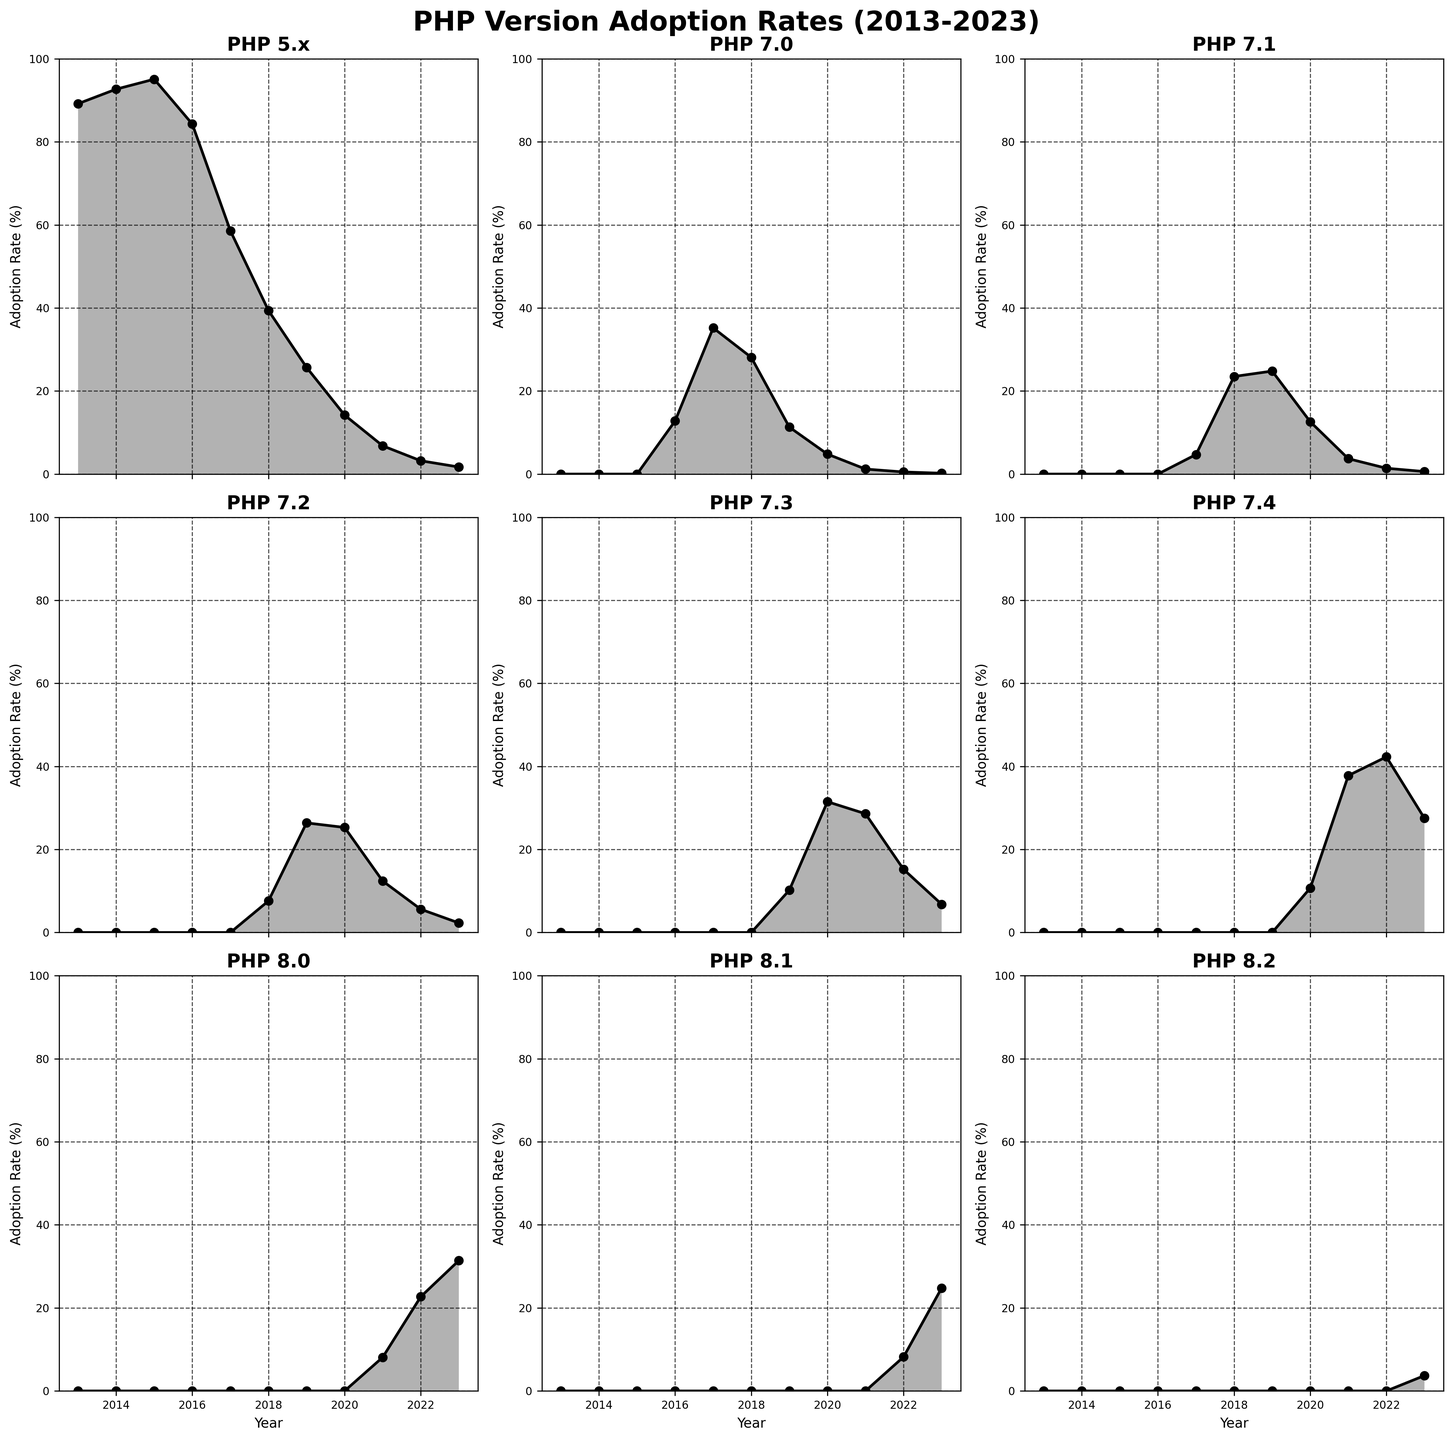What's the title of the figure? The title is usually prominently displayed at the top of the figure. In this case, it's clearly visible as 'PHP Version Adoption Rates (2013-2023)'.
Answer: PHP Version Adoption Rates (2013-2023) Which PHP version had the highest adoption rate in 2016? We need to look at the subplot titled 'PHP 5.x' for the adoption rate in 2016. By checking the figure, 'PHP 5.x' shows an adoption rate around 84.3%.
Answer: PHP 5.x How did PHP 7.0's adoption rate change between 2016 and 2017? By examining the 'PHP 7.0' subplot, we see the adoption rate went from 12.8% in 2016 to 35.2% in 2017. The change is calculated by subtraction: 35.2% - 12.8% = 22.4%.
Answer: Increased by 22.4% Which PHP version had a consistently increasing adoption rate from 2019 to 2023? Examining each subplot from 2019 to 2023, we see 'PHP 8.0' has a consistent increase from 0% to 31.4%.
Answer: PHP 8.0 In 2020, which PHP version had the highest adoption rate and what was it? Look at the highest point in the 2020 data across all subplots. PHP 7.3 had the highest adoption rate at 31.5%.
Answer: PHP 7.3, 31.5% What was the adoption rate for PHP 5.x in 2023 and how does it compare to PHP 8.1? Refer to the values for 2023 in both 'PHP 5.x' and 'PHP 8.1' subplots. PHP 5.x had an adoption rate of 1.7%, while PHP 8.1 had 24.8%. To compare, PHP 8.1 is significantly higher.
Answer: PHP 5.x: 1.7%, PHP 8.1: 24.8% Did any version show a decline in adoption rate from 2022 to 2023? By checking each subplot from 2022 to 2023, we see PHP 7.4 shows a decline from 42.3% to 27.5%.
Answer: Yes, PHP 7.4 Calculate the average adoption rate of PHP 7.4 from 2020 to 2023. Find the data points for PHP 7.4 from 2020 to 2023: 10.7%, 37.8%, 42.3%, and 27.5%. Summing them up gives 118.3%, and the average is 118.3% / 4 = 29.575%.
Answer: 29.575% Which year did PHP 7.2 surpass PHP 7.0 in adoption rate? Compare the adoption rates of PHP 7.2 and PHP 7.0 year by year. In 2019, PHP 7.2 (26.4%) surpassed PHP 7.0 (11.3%).
Answer: 2019 